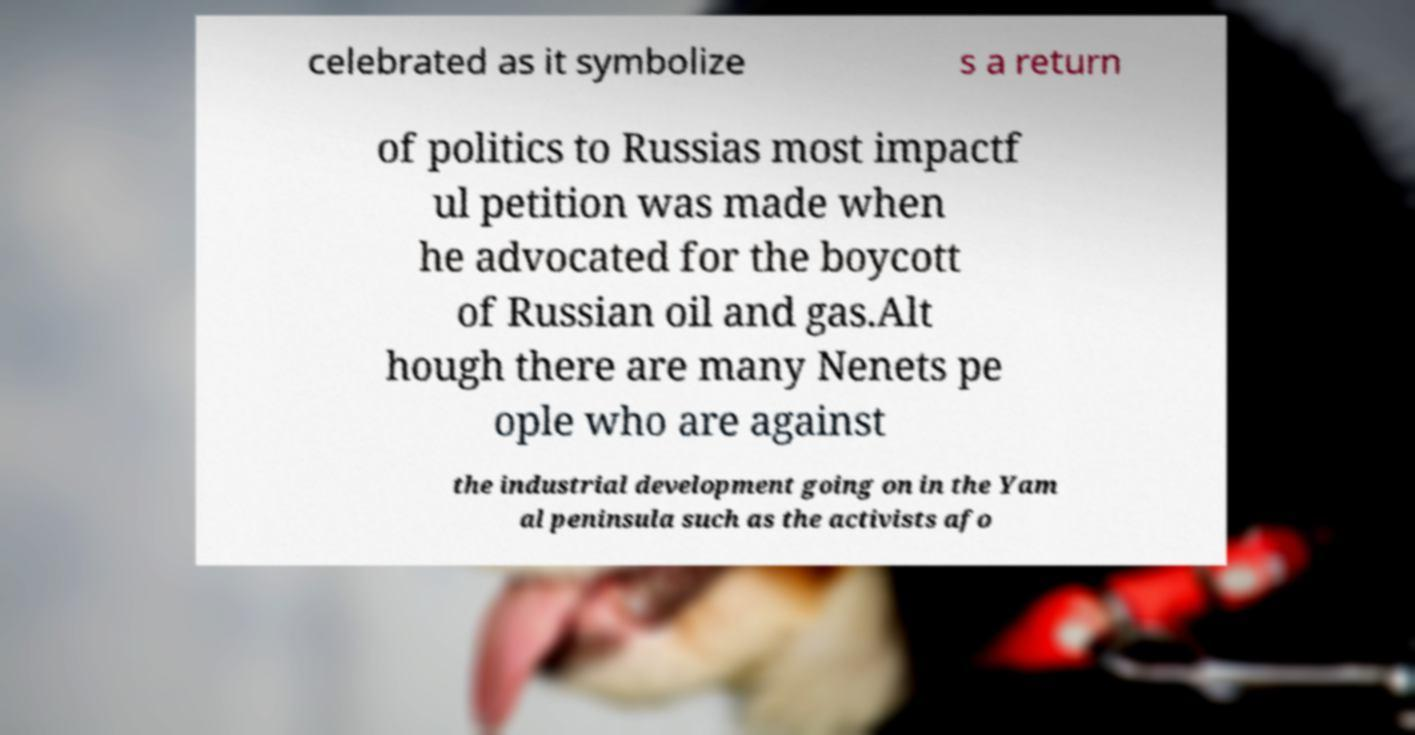Please identify and transcribe the text found in this image. celebrated as it symbolize s a return of politics to Russias most impactf ul petition was made when he advocated for the boycott of Russian oil and gas.Alt hough there are many Nenets pe ople who are against the industrial development going on in the Yam al peninsula such as the activists afo 